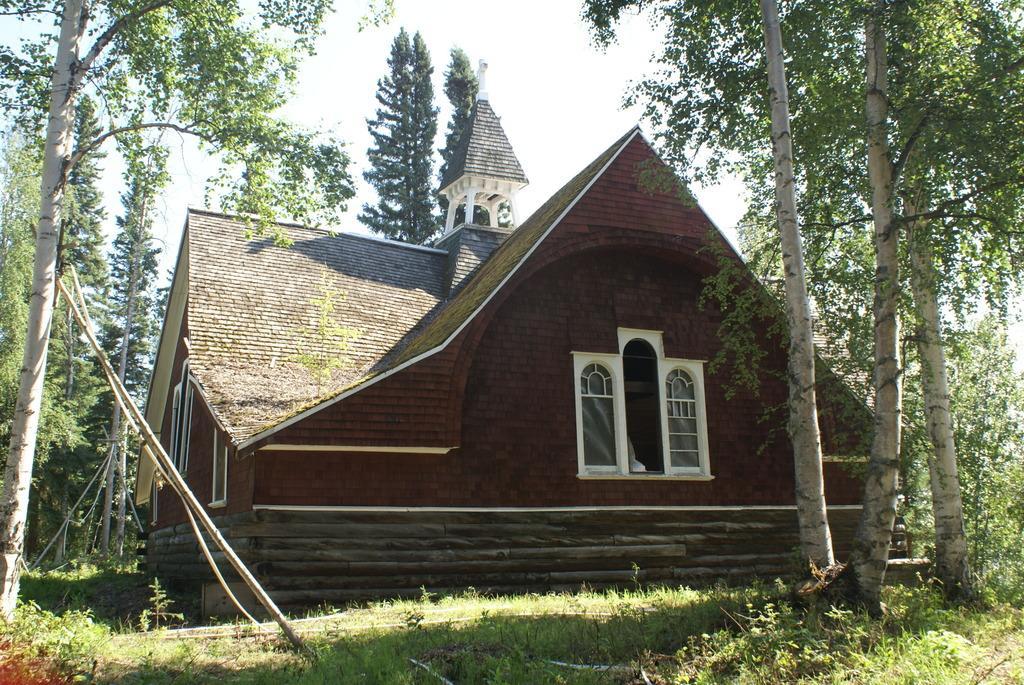How would you summarize this image in a sentence or two? In this image in the center there is one house, and on the right side and left side there are some trees. At the bottom there is grass and at the top there is sky. 